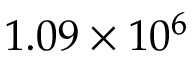<formula> <loc_0><loc_0><loc_500><loc_500>1 . 0 9 \times 1 0 ^ { 6 }</formula> 